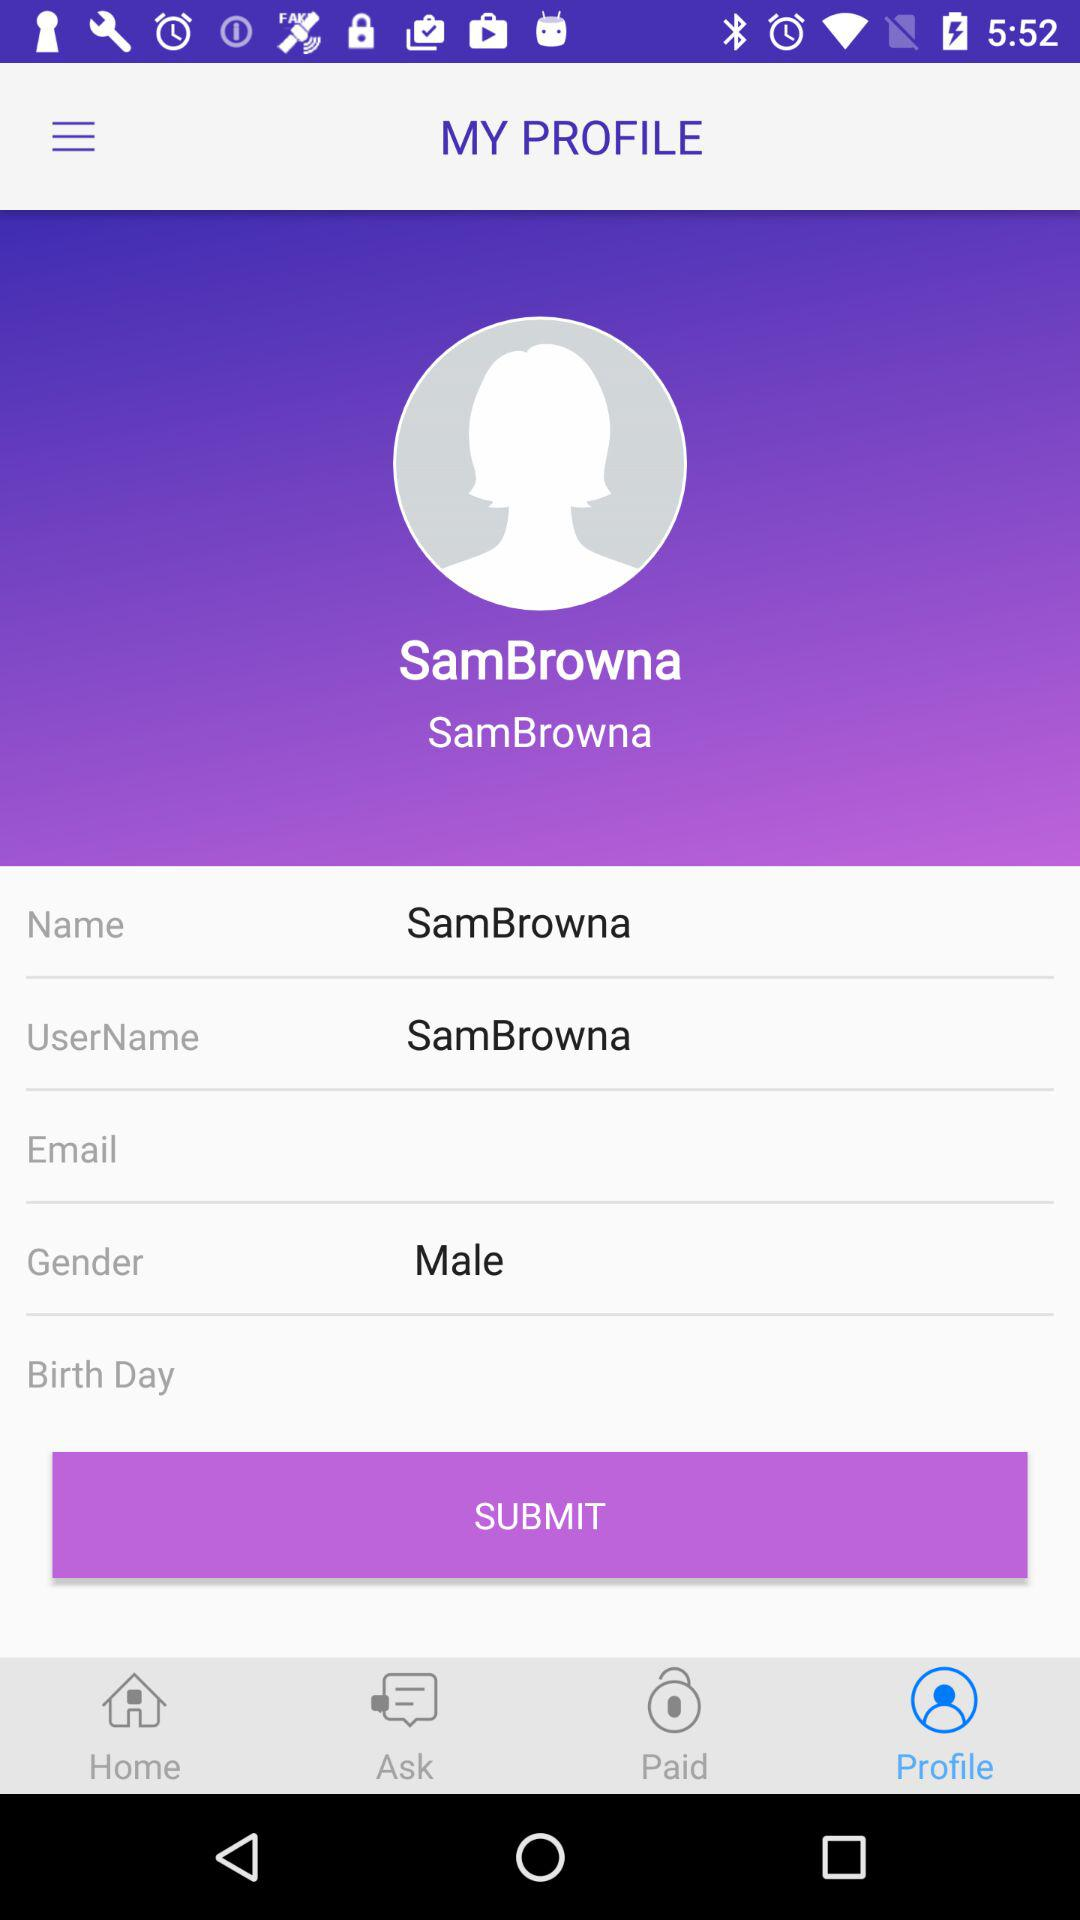What is the mentioned gender? The mentioned gender is male. 